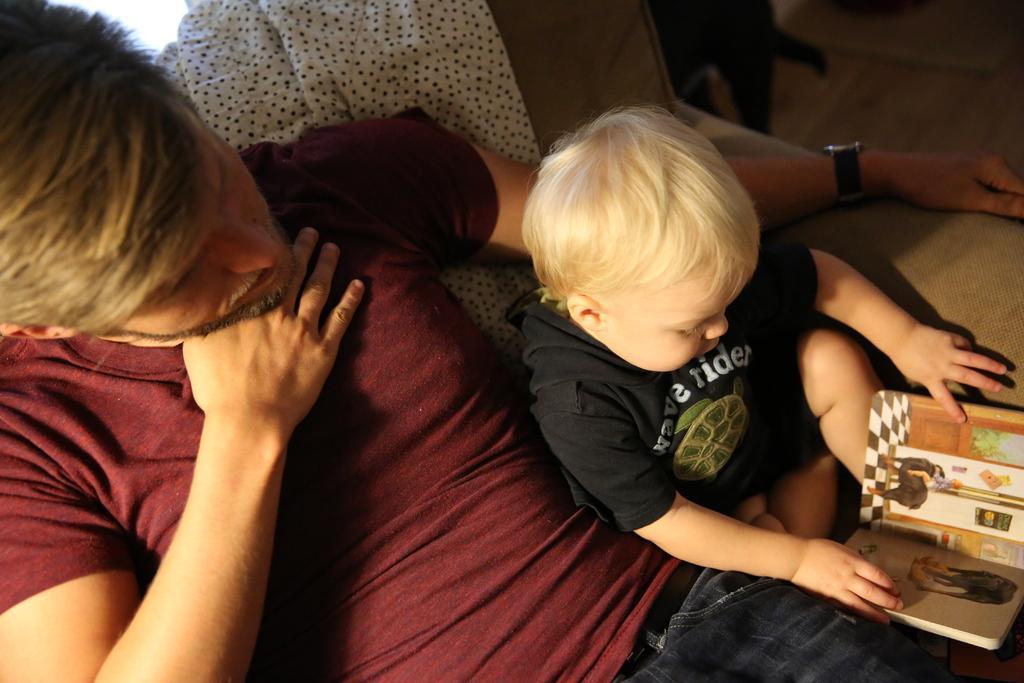In one or two sentences, can you explain what this image depicts? On the left side there is a man sitting on a couch and looking at the baby who is beside him. The baby is sitting, holding a book in the hands and looking into the book. At the back of this man there is a white color cloth placed on the couch. I can see a watch to his left hand. 